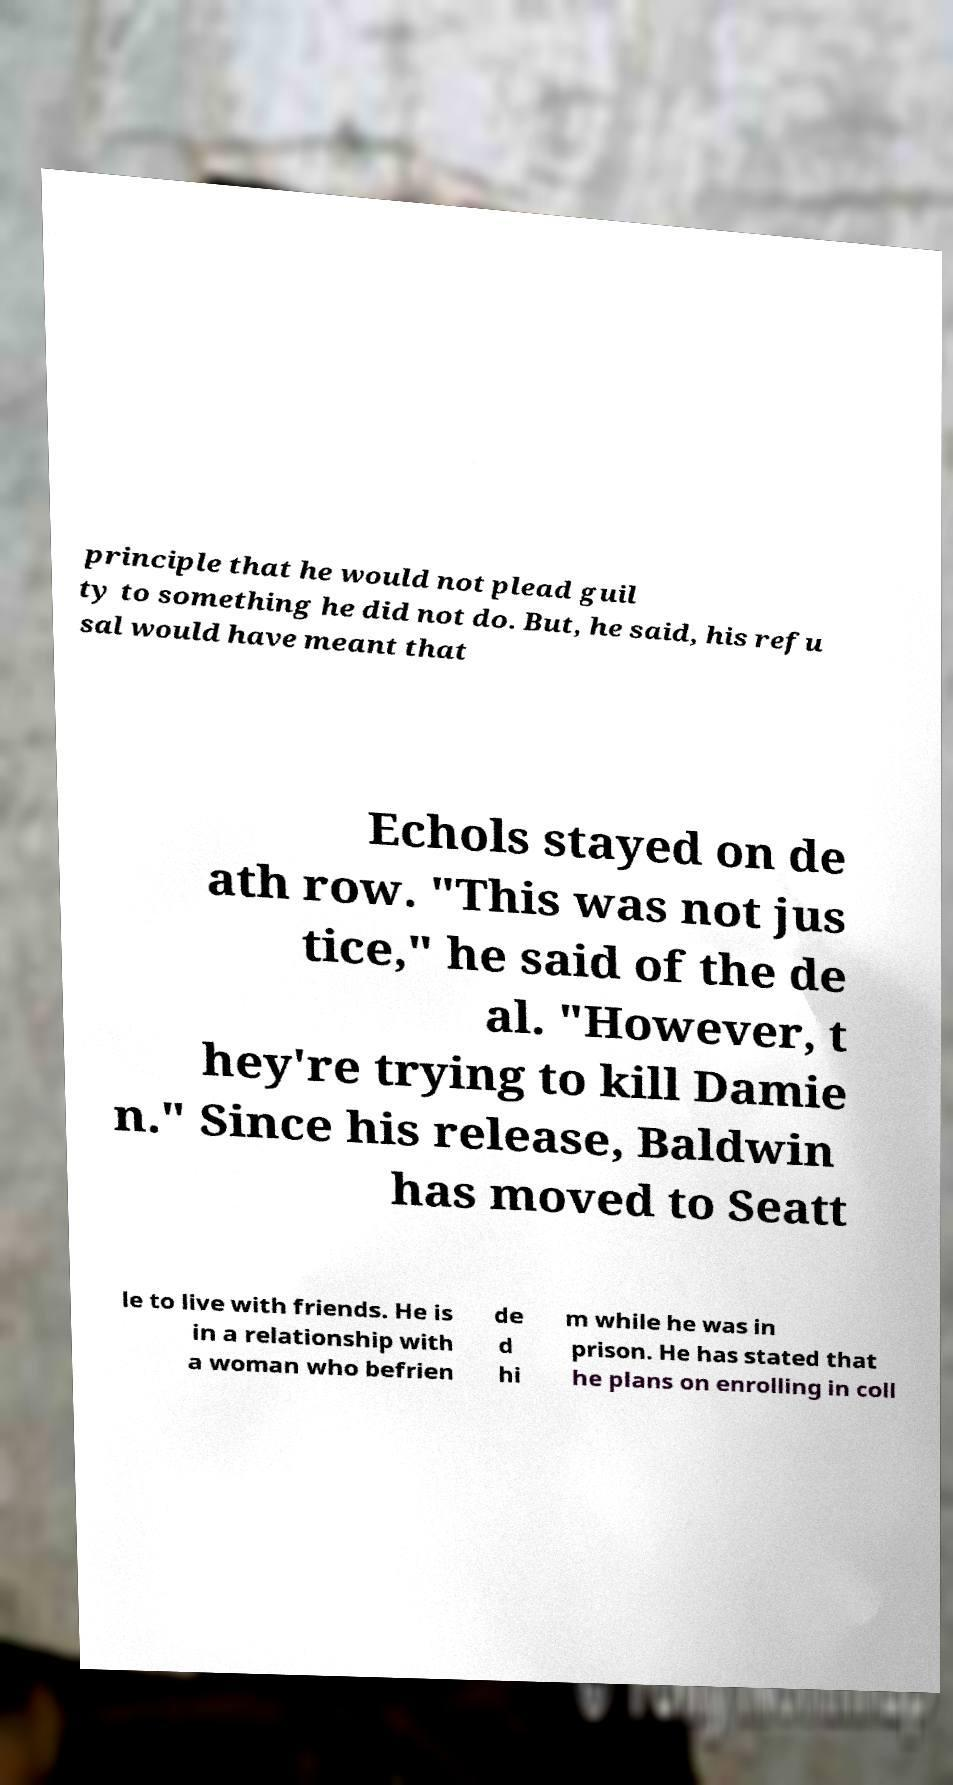Please read and relay the text visible in this image. What does it say? principle that he would not plead guil ty to something he did not do. But, he said, his refu sal would have meant that Echols stayed on de ath row. "This was not jus tice," he said of the de al. "However, t hey're trying to kill Damie n." Since his release, Baldwin has moved to Seatt le to live with friends. He is in a relationship with a woman who befrien de d hi m while he was in prison. He has stated that he plans on enrolling in coll 